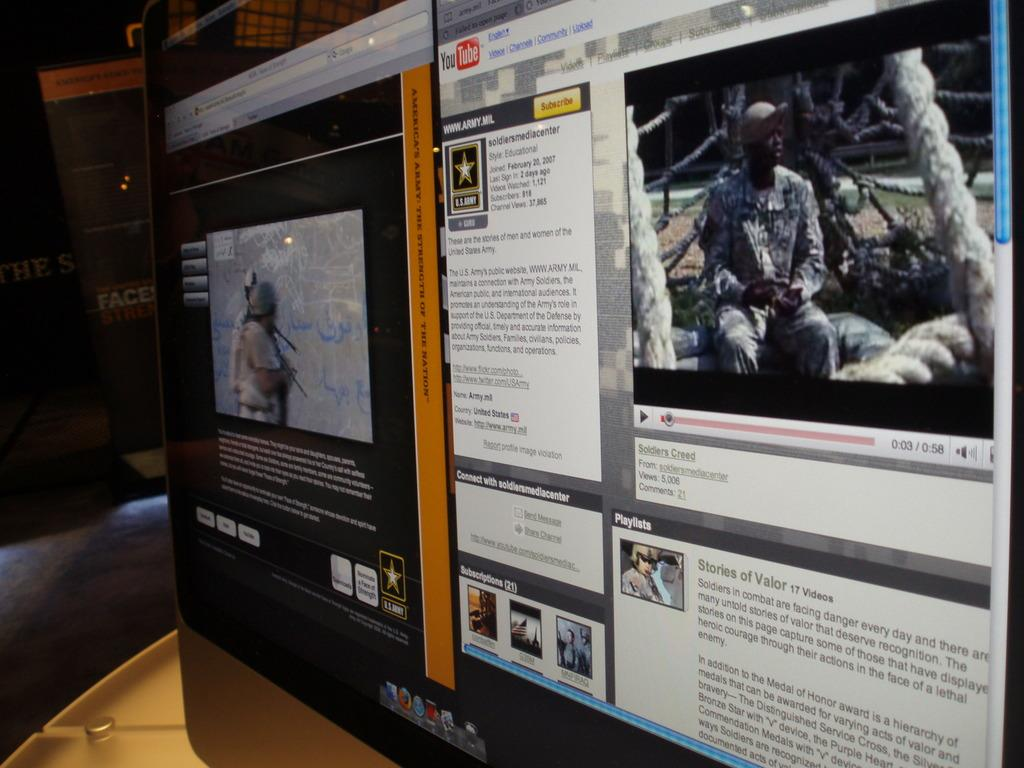What is the main object in the image? There is a screen in the image. What can be seen on the screen? There are persons visible on the screen, and there is text or writing on the screen. How would you describe the overall lighting in the image? The background of the image is dark. What type of bread is being served to the goldfish in the image? There is no bread or goldfish present in the image. What flavor of soda is being consumed by the persons on the screen? The image does not provide information about the consumption of soda by the persons on the screen. 